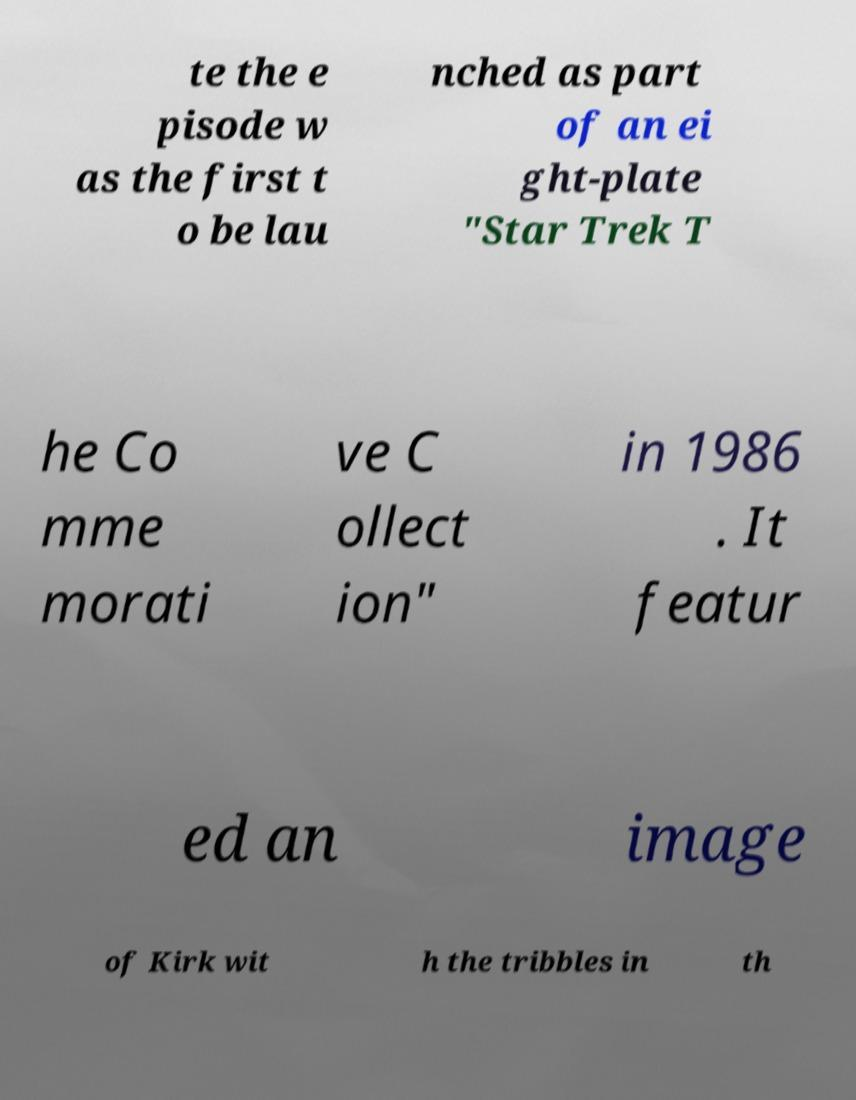Please read and relay the text visible in this image. What does it say? te the e pisode w as the first t o be lau nched as part of an ei ght-plate "Star Trek T he Co mme morati ve C ollect ion" in 1986 . It featur ed an image of Kirk wit h the tribbles in th 